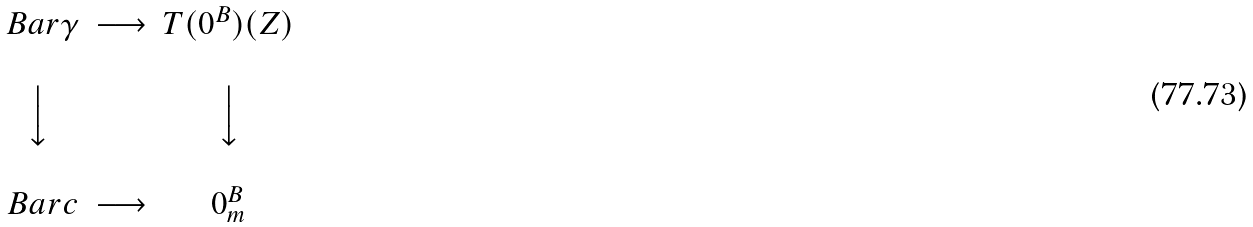Convert formula to latex. <formula><loc_0><loc_0><loc_500><loc_500>\begin{matrix} & & & \\ & \ B a r { \gamma } & \longrightarrow & T ( 0 ^ { B } ) ( Z ) \\ & & & \\ & \Big \downarrow & & \Big \downarrow \\ & & & \\ & \ B a r { c } & \longrightarrow & 0 ^ { B } _ { m } \\ \end{matrix}</formula> 